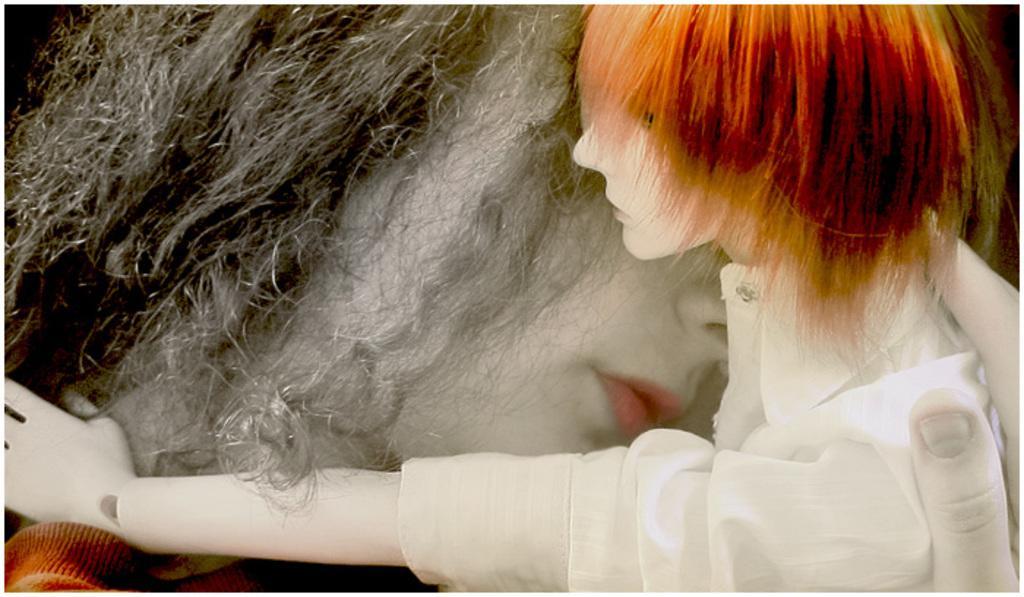Describe this image in one or two sentences. In this image we can see two dolls, one dollar is holding the other doll. 